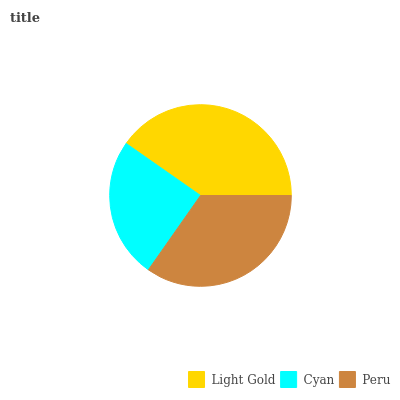Is Cyan the minimum?
Answer yes or no. Yes. Is Light Gold the maximum?
Answer yes or no. Yes. Is Peru the minimum?
Answer yes or no. No. Is Peru the maximum?
Answer yes or no. No. Is Peru greater than Cyan?
Answer yes or no. Yes. Is Cyan less than Peru?
Answer yes or no. Yes. Is Cyan greater than Peru?
Answer yes or no. No. Is Peru less than Cyan?
Answer yes or no. No. Is Peru the high median?
Answer yes or no. Yes. Is Peru the low median?
Answer yes or no. Yes. Is Light Gold the high median?
Answer yes or no. No. Is Light Gold the low median?
Answer yes or no. No. 